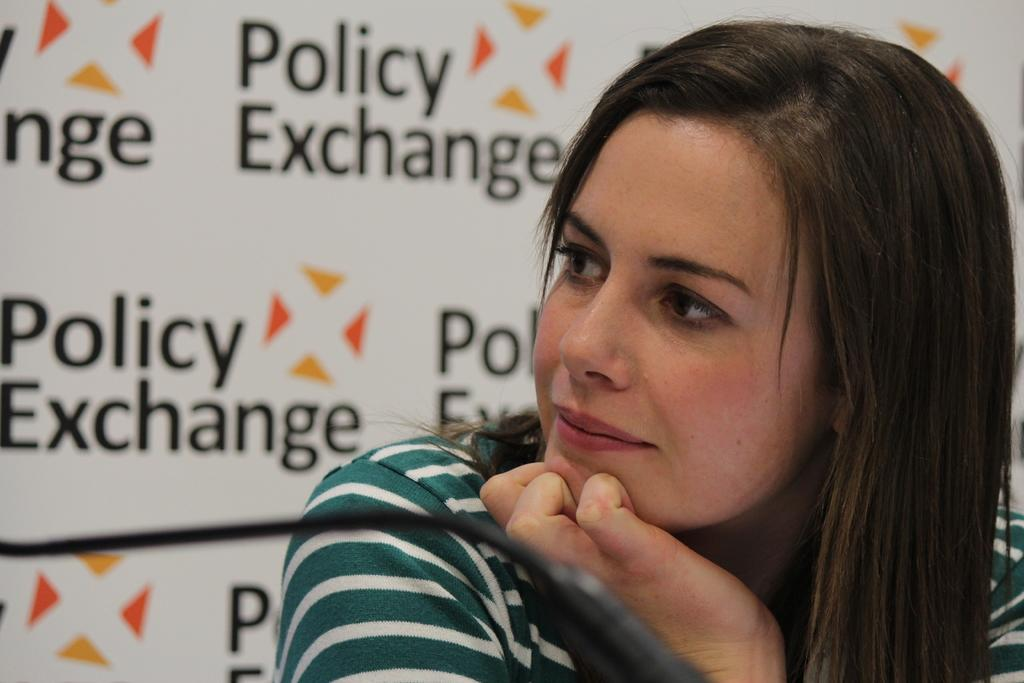What is the person in the image wearing? The person in the image is wearing a white and cream color dress. What can be seen in the background of the image? There is a banner visible in the image. What is written on the banner? The name "Policy Exchange" is written on the banner. Can you hear the person in the image talking about their recent loss? There is no indication of a loss or any conversation in the image, as it only shows a person wearing a dress and a banner with "Policy Exchange" written on it. 